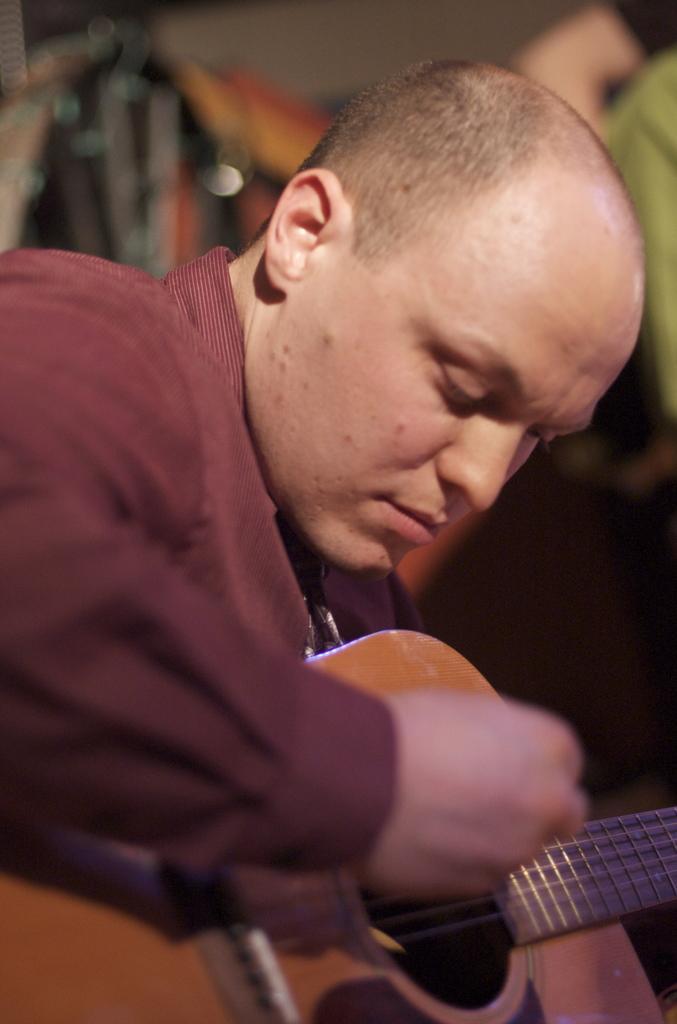Could you give a brief overview of what you see in this image? In this image there is one person who is sitting, and he is holding a guitar and he is wearing red shirt. 